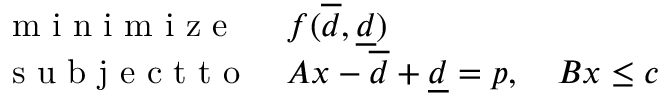<formula> <loc_0><loc_0><loc_500><loc_500>\begin{array} { l l } { m i n i m i z e } & { f ( \overline { d } , \underline { d } ) } \\ { s u b j e c t t o } & { A x - \overline { d } + \underline { d } = p , \quad B x \leq c } \end{array}</formula> 